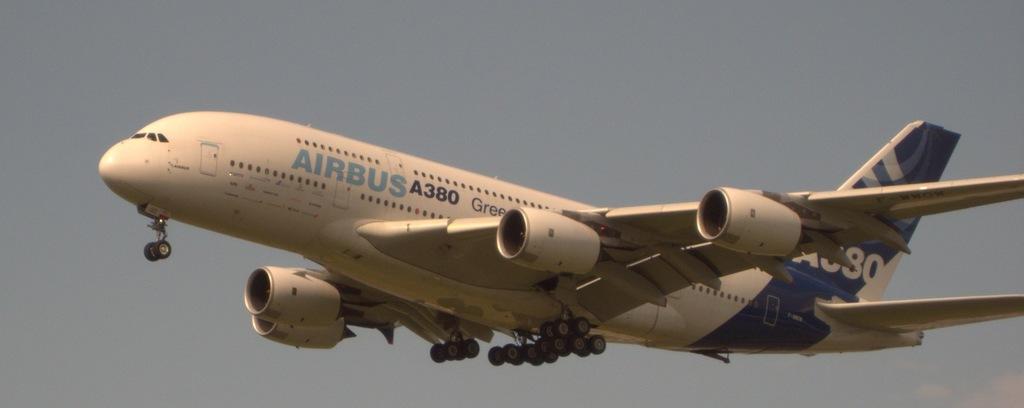What does the white sign say?
Your answer should be compact. Unanswerable. What model of plane is this?
Give a very brief answer. Airbus a380. 